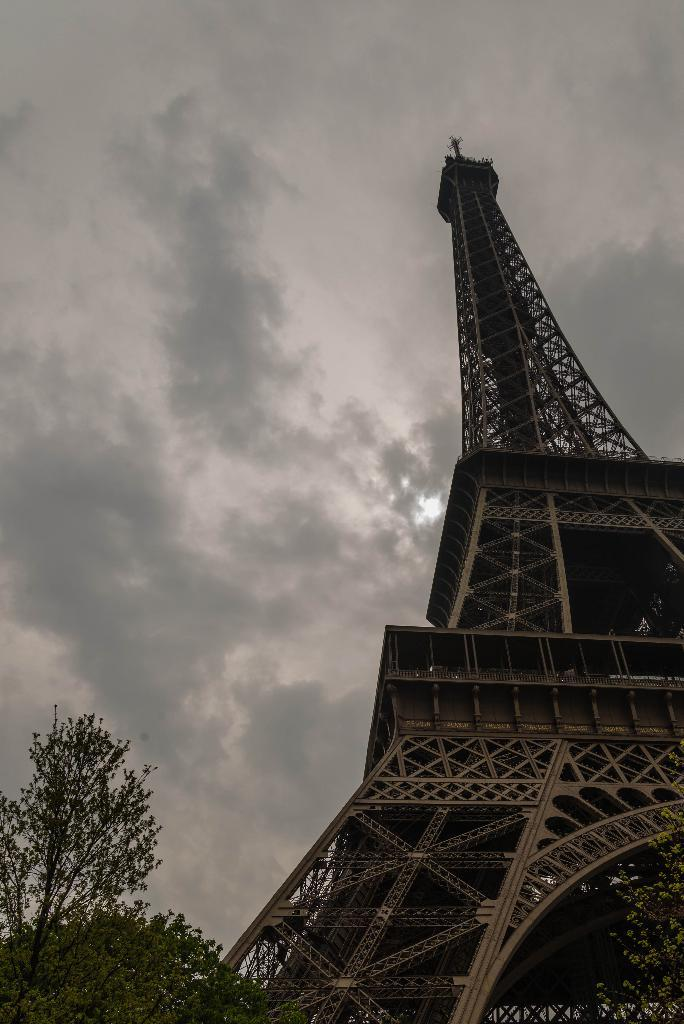What is located in the foreground area of the image? There is a tree and a tower in the foreground area of the image. Can you describe the tree in the image? The tree is located in the foreground area of the image. What is visible in the background of the image? The sky is visible in the background of the image. What type of war is being depicted in the image? There is no depiction of war in the image; it features a tree and a tower in the foreground area and the sky in the background. What type of property is visible in the image? There is no specific property visible in the image; it primarily features a tree, a tower, and the sky. 